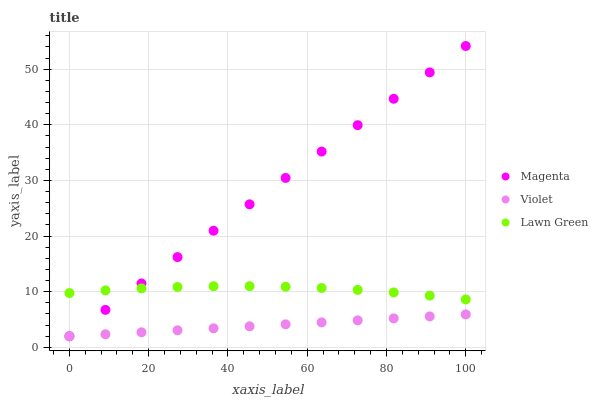Does Violet have the minimum area under the curve?
Answer yes or no. Yes. Does Magenta have the maximum area under the curve?
Answer yes or no. Yes. Does Magenta have the minimum area under the curve?
Answer yes or no. No. Does Violet have the maximum area under the curve?
Answer yes or no. No. Is Violet the smoothest?
Answer yes or no. Yes. Is Lawn Green the roughest?
Answer yes or no. Yes. Is Magenta the smoothest?
Answer yes or no. No. Is Magenta the roughest?
Answer yes or no. No. Does Magenta have the lowest value?
Answer yes or no. Yes. Does Magenta have the highest value?
Answer yes or no. Yes. Does Violet have the highest value?
Answer yes or no. No. Is Violet less than Lawn Green?
Answer yes or no. Yes. Is Lawn Green greater than Violet?
Answer yes or no. Yes. Does Lawn Green intersect Magenta?
Answer yes or no. Yes. Is Lawn Green less than Magenta?
Answer yes or no. No. Is Lawn Green greater than Magenta?
Answer yes or no. No. Does Violet intersect Lawn Green?
Answer yes or no. No. 